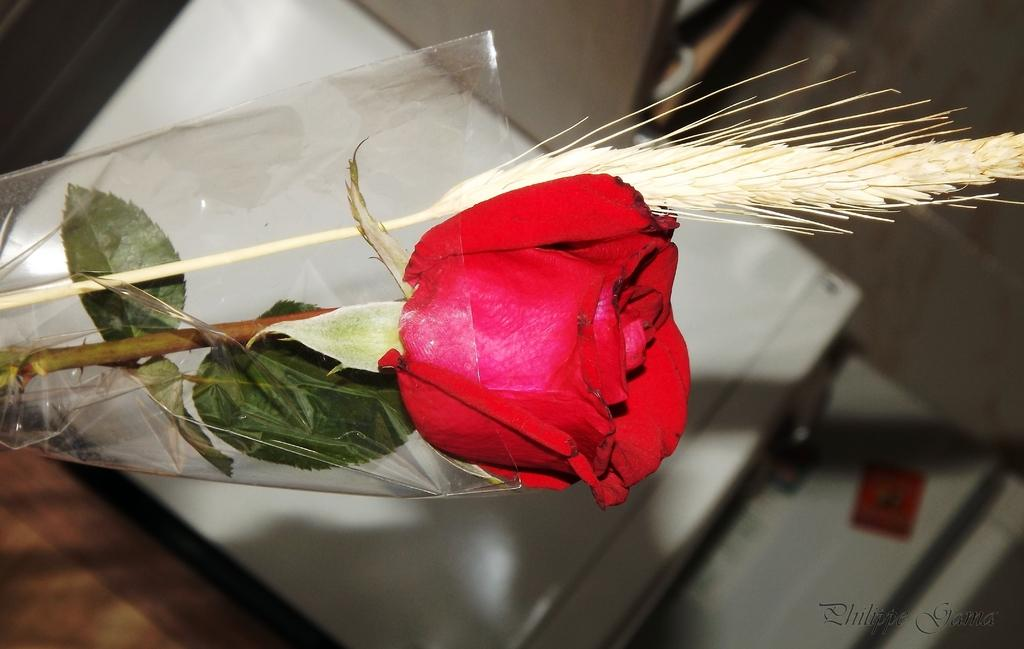What type of flower is in the image? There is a red color rose flower in the image. Can you describe the background of the image? The background of the image is blurred. What type of mint can be seen growing on the sidewalk in the image? There is no mint or sidewalk present in the image; it features a red color rose flower with a blurred background. 